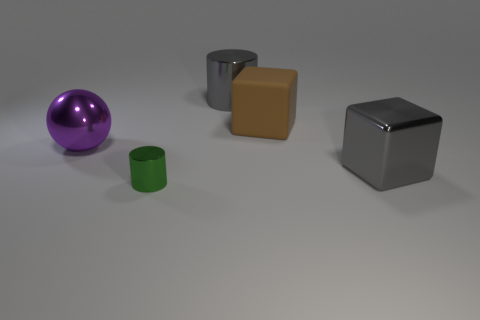Subtract all cyan spheres. Subtract all red cylinders. How many spheres are left? 1 Add 3 small green metal objects. How many objects exist? 8 Subtract all cylinders. How many objects are left? 3 Subtract all tiny cyan cylinders. Subtract all gray metal blocks. How many objects are left? 4 Add 3 gray blocks. How many gray blocks are left? 4 Add 3 large green balls. How many large green balls exist? 3 Subtract 0 green balls. How many objects are left? 5 